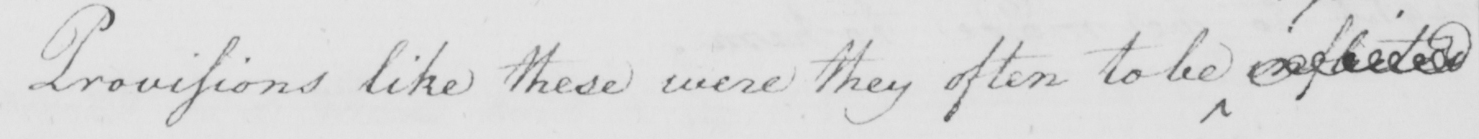Can you tell me what this handwritten text says? Provisions like these were they often to be   <gap/> 